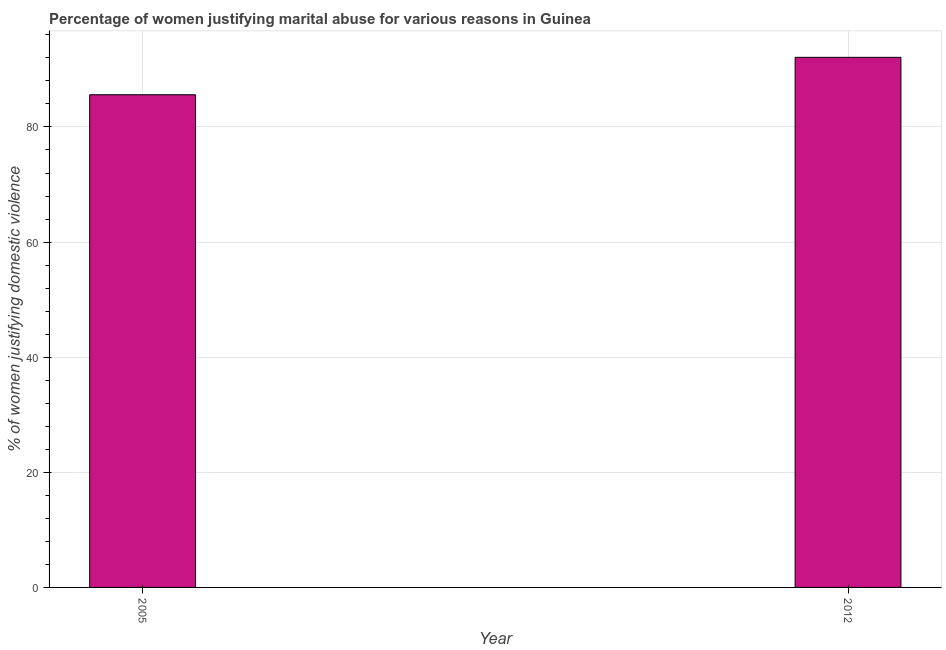Does the graph contain any zero values?
Offer a terse response. No. What is the title of the graph?
Ensure brevity in your answer.  Percentage of women justifying marital abuse for various reasons in Guinea. What is the label or title of the X-axis?
Offer a very short reply. Year. What is the label or title of the Y-axis?
Your response must be concise. % of women justifying domestic violence. What is the percentage of women justifying marital abuse in 2012?
Keep it short and to the point. 92.1. Across all years, what is the maximum percentage of women justifying marital abuse?
Provide a succinct answer. 92.1. Across all years, what is the minimum percentage of women justifying marital abuse?
Provide a short and direct response. 85.6. In which year was the percentage of women justifying marital abuse maximum?
Provide a short and direct response. 2012. What is the sum of the percentage of women justifying marital abuse?
Offer a terse response. 177.7. What is the average percentage of women justifying marital abuse per year?
Your answer should be compact. 88.85. What is the median percentage of women justifying marital abuse?
Ensure brevity in your answer.  88.85. In how many years, is the percentage of women justifying marital abuse greater than 48 %?
Offer a very short reply. 2. Do a majority of the years between 2012 and 2005 (inclusive) have percentage of women justifying marital abuse greater than 32 %?
Your response must be concise. No. What is the ratio of the percentage of women justifying marital abuse in 2005 to that in 2012?
Make the answer very short. 0.93. Is the percentage of women justifying marital abuse in 2005 less than that in 2012?
Your response must be concise. Yes. How many bars are there?
Give a very brief answer. 2. Are the values on the major ticks of Y-axis written in scientific E-notation?
Your response must be concise. No. What is the % of women justifying domestic violence of 2005?
Your answer should be very brief. 85.6. What is the % of women justifying domestic violence in 2012?
Make the answer very short. 92.1. What is the ratio of the % of women justifying domestic violence in 2005 to that in 2012?
Your answer should be very brief. 0.93. 